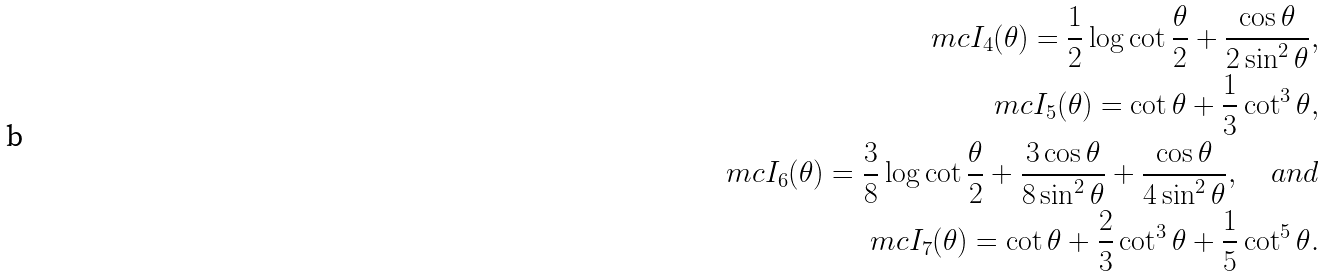<formula> <loc_0><loc_0><loc_500><loc_500>\ m c I _ { 4 } ( \theta ) = \frac { 1 } { 2 } \log \cot \frac { \theta } { 2 } + \frac { \cos \theta } { 2 \sin ^ { 2 } \theta } , \\ \ m c I _ { 5 } ( \theta ) = \cot \theta + \frac { 1 } { 3 } \cot ^ { 3 } \theta , \\ \ m c I _ { 6 } ( \theta ) = \frac { 3 } { 8 } \log \cot \frac { \theta } { 2 } + \frac { 3 \cos \theta } { 8 \sin ^ { 2 } \theta } + \frac { \cos \theta } { 4 \sin ^ { 2 } \theta } , \quad a n d \\ \ m c I _ { 7 } ( \theta ) = \cot \theta + \frac { 2 } { 3 } \cot ^ { 3 } \theta + \frac { 1 } { 5 } \cot ^ { 5 } \theta .</formula> 